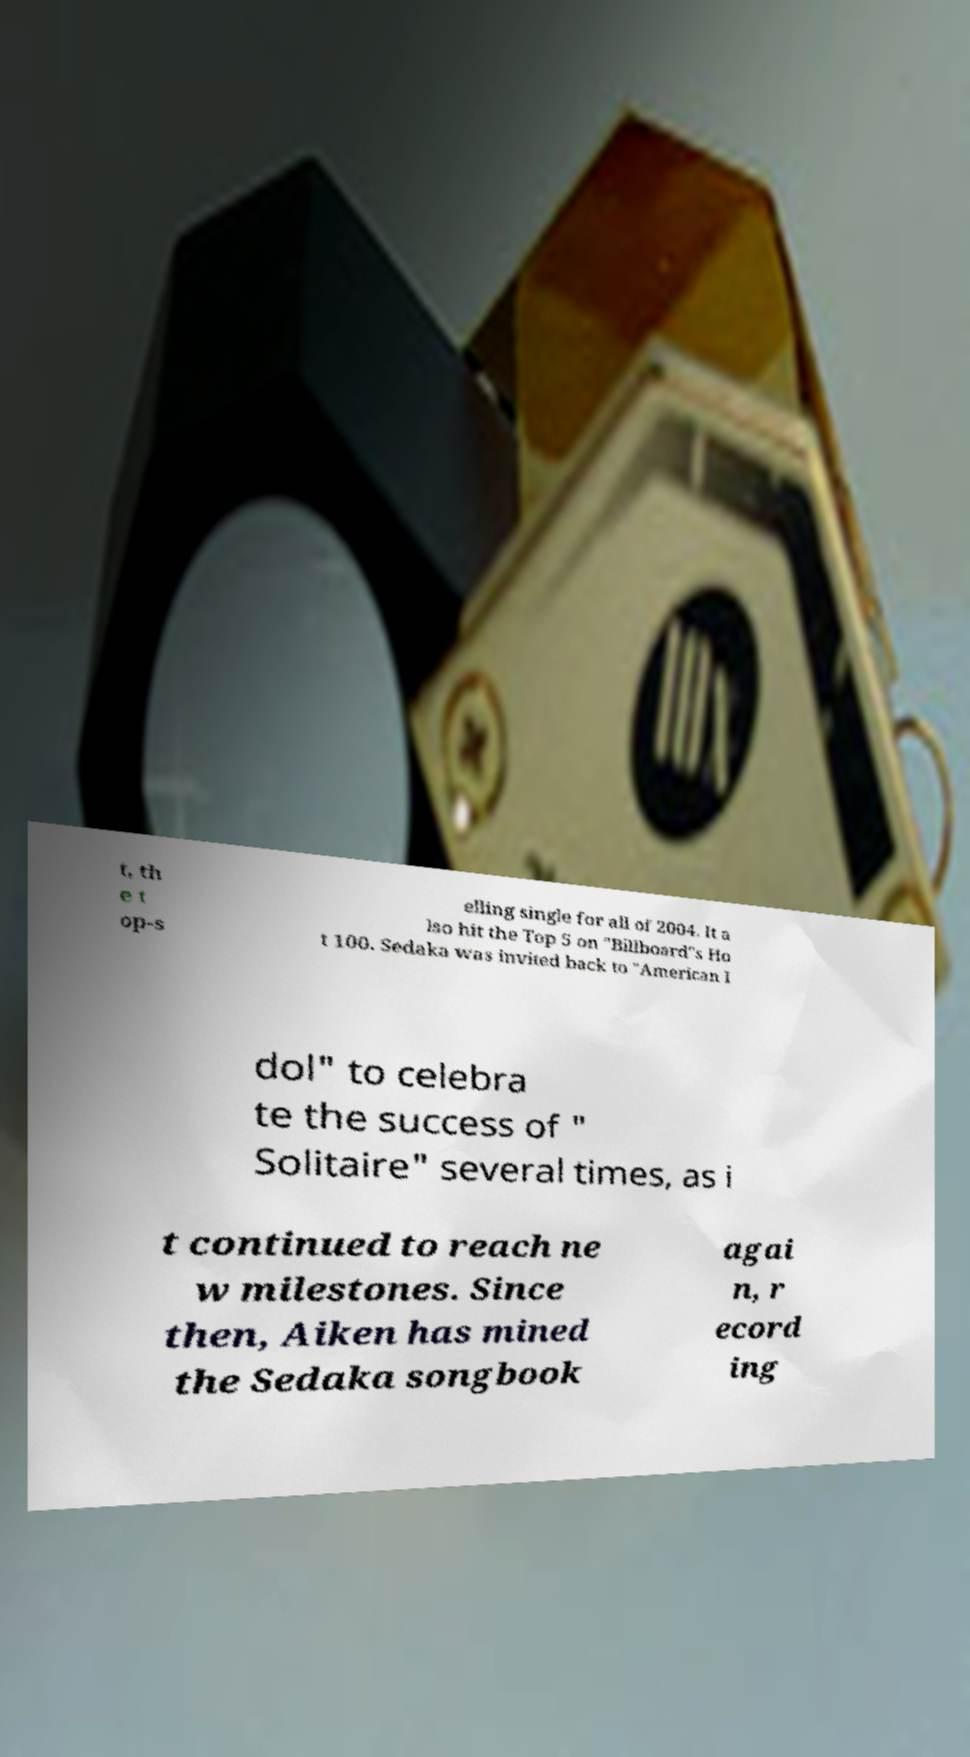Could you assist in decoding the text presented in this image and type it out clearly? t, th e t op-s elling single for all of 2004. It a lso hit the Top 5 on "Billboard"s Ho t 100. Sedaka was invited back to "American I dol" to celebra te the success of " Solitaire" several times, as i t continued to reach ne w milestones. Since then, Aiken has mined the Sedaka songbook agai n, r ecord ing 